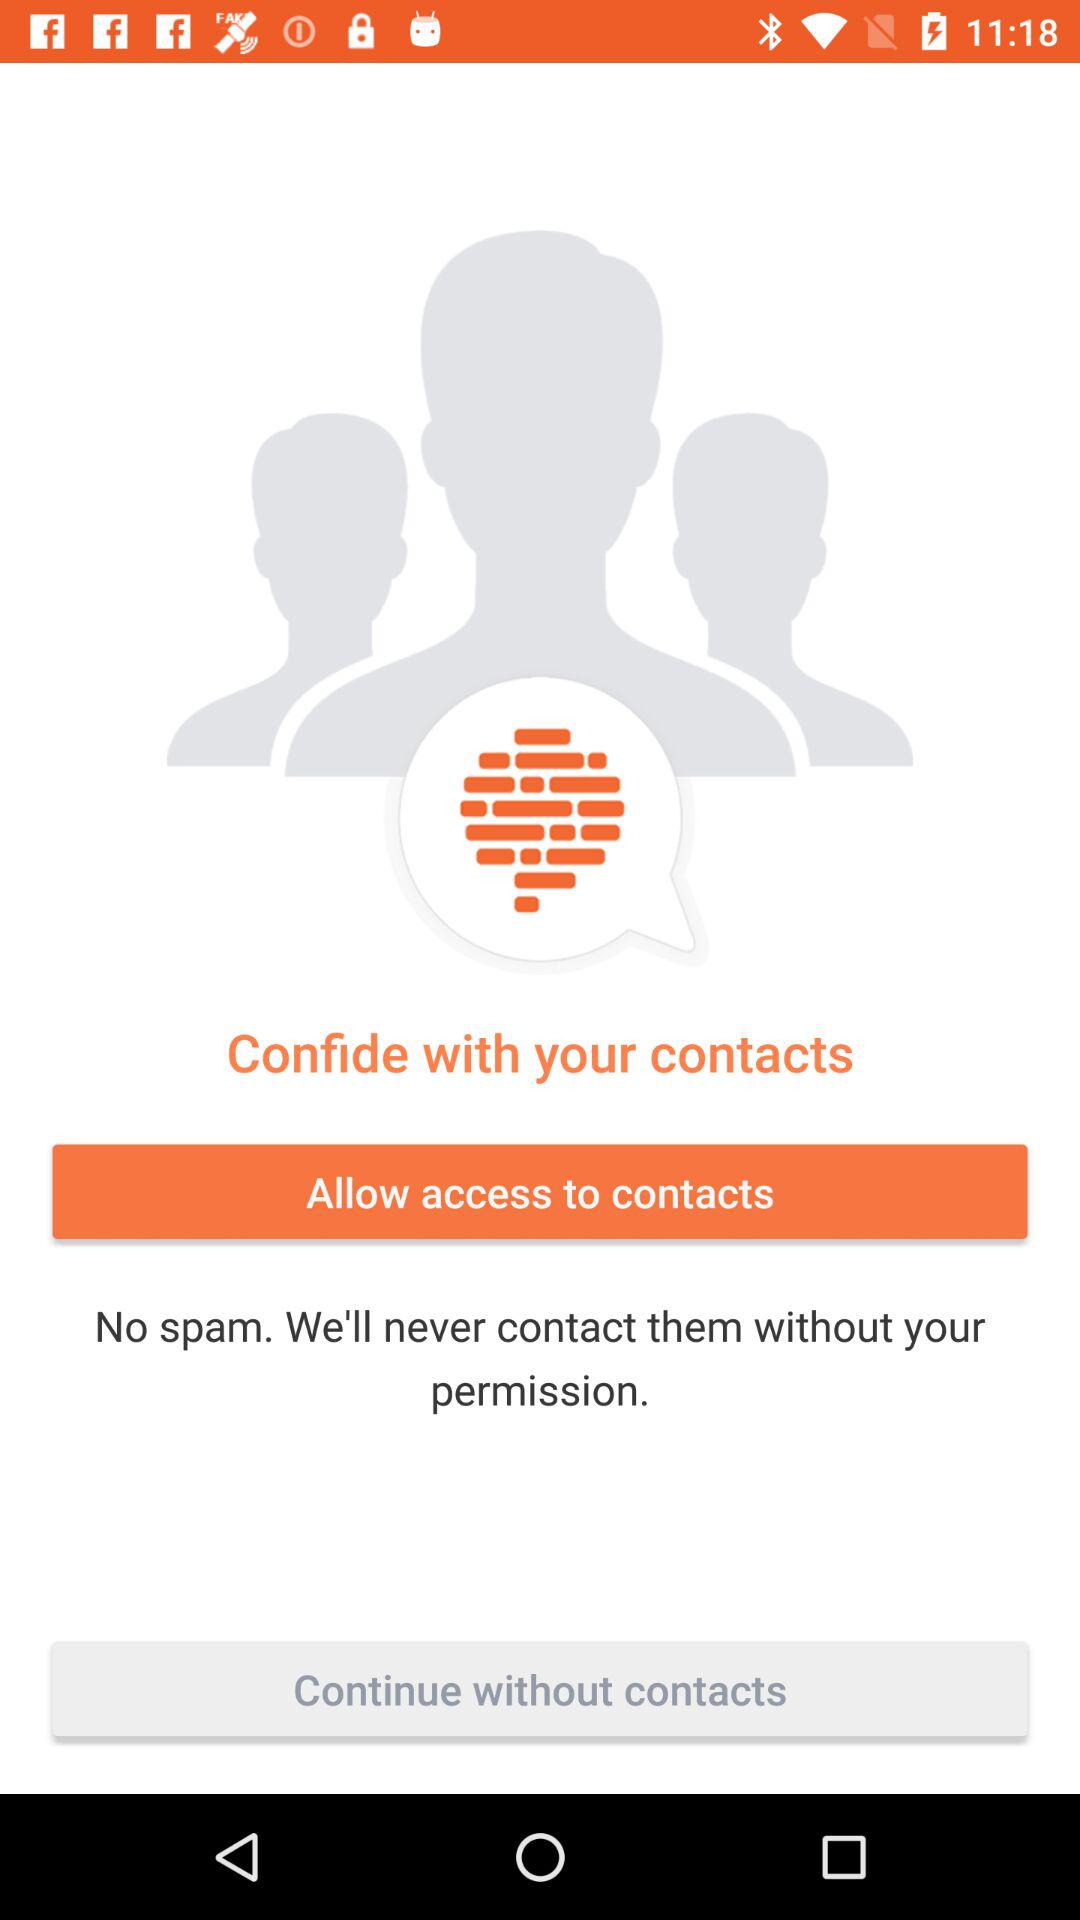Are there any spams shown on the screen? There is no spam shown on the screen. 